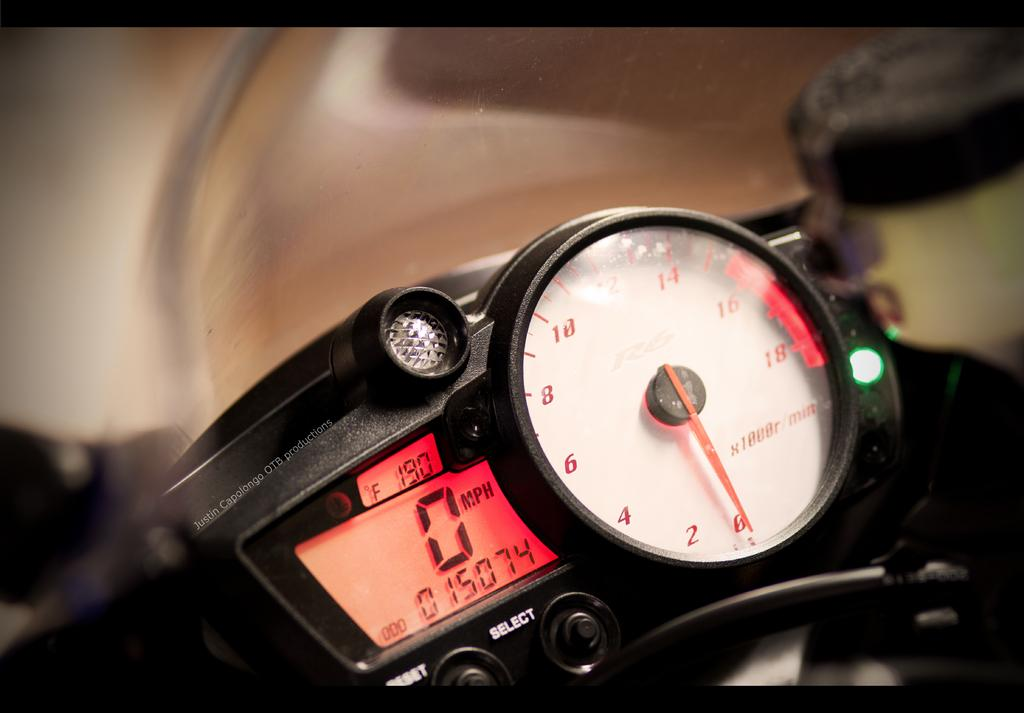What is the main object in the image? There is a speedometer in the image. Can you describe the background of the image? The background of the image is blurred. Where is the faucet located in the image? There is no faucet present in the image. What type of vessel is being used to transport water in the image? There is no vessel or water present in the image. 